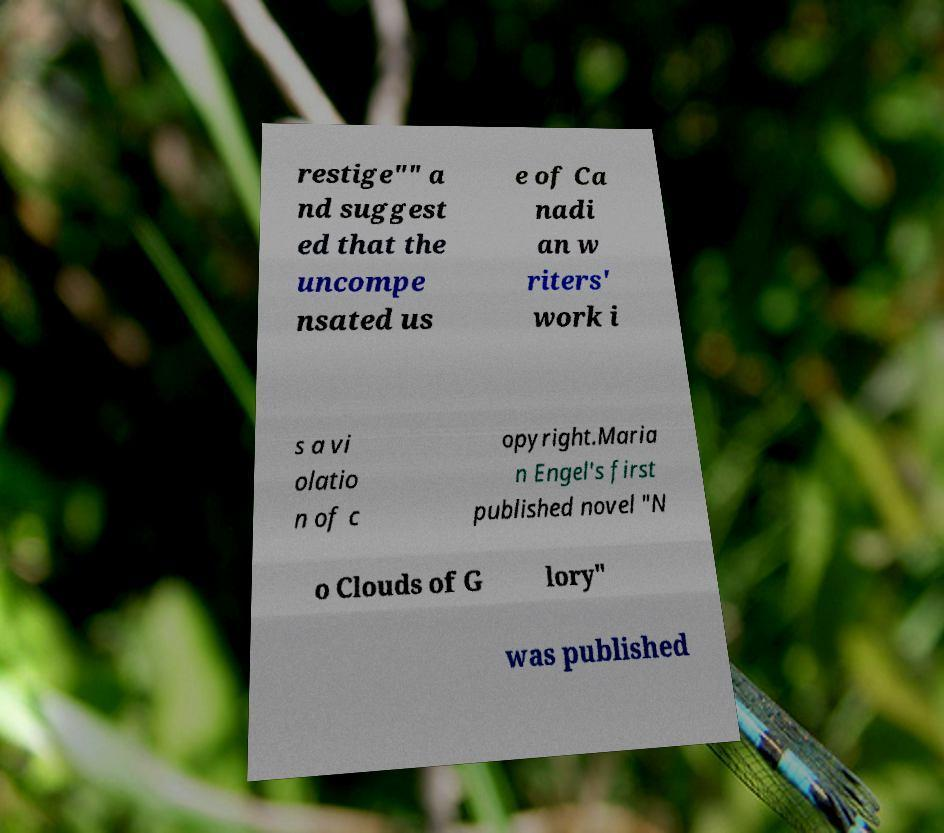Could you extract and type out the text from this image? restige"" a nd suggest ed that the uncompe nsated us e of Ca nadi an w riters' work i s a vi olatio n of c opyright.Maria n Engel's first published novel "N o Clouds of G lory" was published 